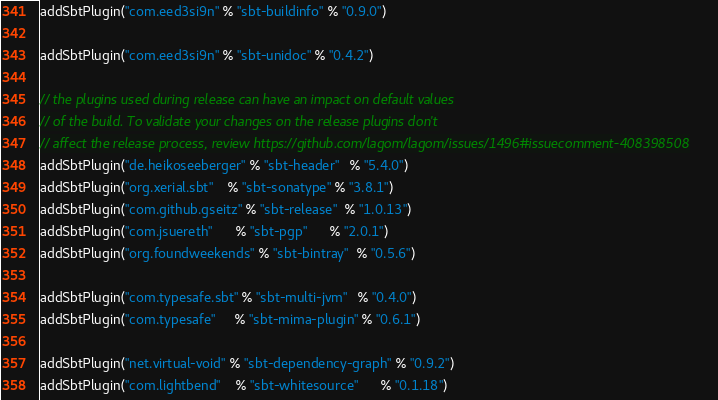Convert code to text. <code><loc_0><loc_0><loc_500><loc_500><_Scala_>addSbtPlugin("com.eed3si9n" % "sbt-buildinfo" % "0.9.0")

addSbtPlugin("com.eed3si9n" % "sbt-unidoc" % "0.4.2")

// the plugins used during release can have an impact on default values
// of the build. To validate your changes on the release plugins don't
// affect the release process, review https://github.com/lagom/lagom/issues/1496#issuecomment-408398508
addSbtPlugin("de.heikoseeberger" % "sbt-header"   % "5.4.0")
addSbtPlugin("org.xerial.sbt"    % "sbt-sonatype" % "3.8.1")
addSbtPlugin("com.github.gseitz" % "sbt-release"  % "1.0.13")
addSbtPlugin("com.jsuereth"      % "sbt-pgp"      % "2.0.1")
addSbtPlugin("org.foundweekends" % "sbt-bintray"  % "0.5.6")

addSbtPlugin("com.typesafe.sbt" % "sbt-multi-jvm"   % "0.4.0")
addSbtPlugin("com.typesafe"     % "sbt-mima-plugin" % "0.6.1")

addSbtPlugin("net.virtual-void" % "sbt-dependency-graph" % "0.9.2")
addSbtPlugin("com.lightbend"    % "sbt-whitesource"      % "0.1.18")
</code> 